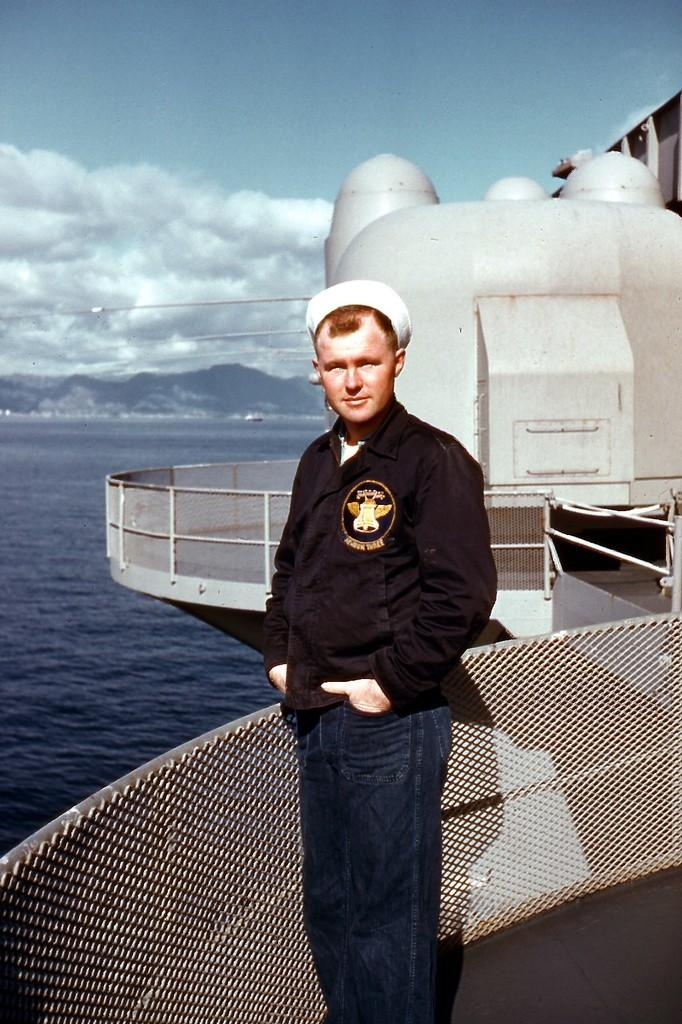What is the person in the image standing on? The person is standing on a ship. Where is the ship located in the image? The ship is on a river. What can be seen in the background of the image? There are mountains and the sky visible in the background of the image. What type of owl can be seen perched on the ship's mast in the image? There is no owl present in the image; it only features a person standing on a ship. What kind of quartz is visible on the riverbank in the image? There is no quartz visible in the image; it only shows a ship on a river with mountains and sky in the background. 